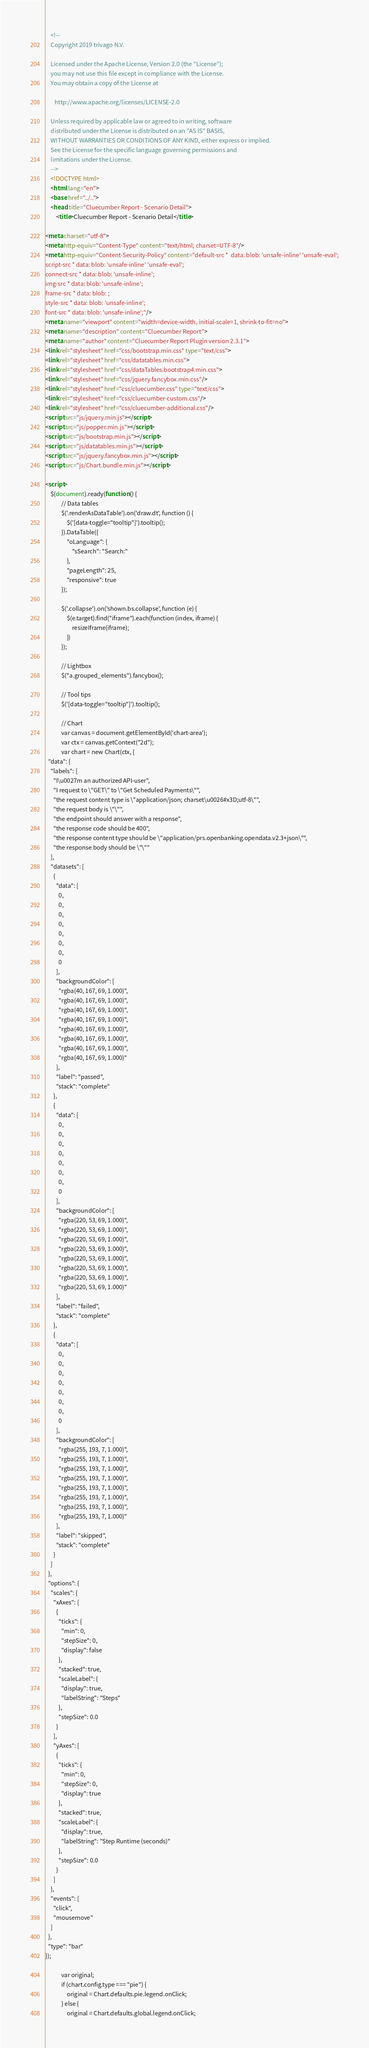Convert code to text. <code><loc_0><loc_0><loc_500><loc_500><_HTML_>
    <!--
    Copyright 2019 trivago N.V.

    Licensed under the Apache License, Version 2.0 (the "License");
    you may not use this file except in compliance with the License.
    You may obtain a copy of the License at

       http://www.apache.org/licenses/LICENSE-2.0

    Unless required by applicable law or agreed to in writing, software
    distributed under the License is distributed on an "AS IS" BASIS,
    WITHOUT WARRANTIES OR CONDITIONS OF ANY KIND, either express or implied.
    See the License for the specific language governing permissions and
    limitations under the License.
    -->
    <!DOCTYPE html>
    <html lang="en">
    <base href="../..">
    <head title="Cluecumber Report - Scenario Detail">
        <title>Cluecumber Report - Scenario Detail</title>

<meta charset="utf-8">
<meta http-equiv="Content-Type" content="text/html; charset=UTF-8"/>
<meta http-equiv="Content-Security-Policy" content="default-src *  data: blob: 'unsafe-inline' 'unsafe-eval';
script-src * data: blob: 'unsafe-inline' 'unsafe-eval';
connect-src * data: blob: 'unsafe-inline';
img-src * data: blob: 'unsafe-inline';
frame-src * data: blob: ;
style-src * data: blob: 'unsafe-inline';
font-src * data: blob: 'unsafe-inline';"/>
<meta name="viewport" content="width=device-width, initial-scale=1, shrink-to-fit=no">
<meta name="description" content="Cluecumber Report">
<meta name="author" content="Cluecumber Report Plugin version 2.3.1">
<link rel="stylesheet" href="css/bootstrap.min.css" type="text/css">
<link rel="stylesheet" href="css/datatables.min.css">
<link rel="stylesheet" href="css/dataTables.bootstrap4.min.css">
<link rel="stylesheet" href="css/jquery.fancybox.min.css"/>
<link rel="stylesheet" href="css/cluecumber.css" type="text/css">
<link rel="stylesheet" href="css/cluecumber-custom.css"/>
<link rel="stylesheet" href="css/cluecumber-additional.css"/>
<script src="js/jquery.min.js"></script>
<script src="js/popper.min.js"></script>
<script src="js/bootstrap.min.js"></script>
<script src="js/datatables.min.js"></script>
<script src="js/jquery.fancybox.min.js"></script>
<script src="js/Chart.bundle.min.js"></script>

<script>
    $(document).ready(function () {
            // Data tables
            $('.renderAsDataTable').on('draw.dt', function () {
                $('[data-toggle="tooltip"]').tooltip();
            }).DataTable({
                "oLanguage": {
                    "sSearch": "Search:"
                },
                "pageLength": 25,
                "responsive": true
            });

            $('.collapse').on('shown.bs.collapse', function (e) {
                $(e.target).find("iframe").each(function (index, iframe) {
                    resizeIframe(iframe);
                })
            });

            // Lightbox
            $("a.grouped_elements").fancybox();

            // Tool tips
            $('[data-toggle="tooltip"]').tooltip();

            // Chart
            var canvas = document.getElementById('chart-area');
            var ctx = canvas.getContext("2d");
            var chart = new Chart(ctx, {
  "data": {
    "labels": [
      "I\u0027m an authorized API-user",
      "I request to \"GET\" to \"Get Scheduled Payments\"",
      "the request content type is \"application/json; charset\u0026#x3D;utf-8\"",
      "the request body is \"\"",
      "the endpoint should answer with a response",
      "the response code should be 400",
      "the response content type should be \"application/prs.openbanking.opendata.v2.3+json\"",
      "the response body should be \"\""
    ],
    "datasets": [
      {
        "data": [
          0,
          0,
          0,
          0,
          0,
          0,
          0,
          0
        ],
        "backgroundColor": [
          "rgba(40, 167, 69, 1.000)",
          "rgba(40, 167, 69, 1.000)",
          "rgba(40, 167, 69, 1.000)",
          "rgba(40, 167, 69, 1.000)",
          "rgba(40, 167, 69, 1.000)",
          "rgba(40, 167, 69, 1.000)",
          "rgba(40, 167, 69, 1.000)",
          "rgba(40, 167, 69, 1.000)"
        ],
        "label": "passed",
        "stack": "complete"
      },
      {
        "data": [
          0,
          0,
          0,
          0,
          0,
          0,
          0,
          0
        ],
        "backgroundColor": [
          "rgba(220, 53, 69, 1.000)",
          "rgba(220, 53, 69, 1.000)",
          "rgba(220, 53, 69, 1.000)",
          "rgba(220, 53, 69, 1.000)",
          "rgba(220, 53, 69, 1.000)",
          "rgba(220, 53, 69, 1.000)",
          "rgba(220, 53, 69, 1.000)",
          "rgba(220, 53, 69, 1.000)"
        ],
        "label": "failed",
        "stack": "complete"
      },
      {
        "data": [
          0,
          0,
          0,
          0,
          0,
          0,
          0,
          0
        ],
        "backgroundColor": [
          "rgba(255, 193, 7, 1.000)",
          "rgba(255, 193, 7, 1.000)",
          "rgba(255, 193, 7, 1.000)",
          "rgba(255, 193, 7, 1.000)",
          "rgba(255, 193, 7, 1.000)",
          "rgba(255, 193, 7, 1.000)",
          "rgba(255, 193, 7, 1.000)",
          "rgba(255, 193, 7, 1.000)"
        ],
        "label": "skipped",
        "stack": "complete"
      }
    ]
  },
  "options": {
    "scales": {
      "xAxes": [
        {
          "ticks": {
            "min": 0,
            "stepSize": 0,
            "display": false
          },
          "stacked": true,
          "scaleLabel": {
            "display": true,
            "labelString": "Steps"
          },
          "stepSize": 0.0
        }
      ],
      "yAxes": [
        {
          "ticks": {
            "min": 0,
            "stepSize": 0,
            "display": true
          },
          "stacked": true,
          "scaleLabel": {
            "display": true,
            "labelString": "Step Runtime (seconds)"
          },
          "stepSize": 0.0
        }
      ]
    },
    "events": [
      "click",
      "mousemove"
    ]
  },
  "type": "bar"
});

            var original;
            if (chart.config.type === "pie") {
                original = Chart.defaults.pie.legend.onClick;
            } else {
                original = Chart.defaults.global.legend.onClick;</code> 